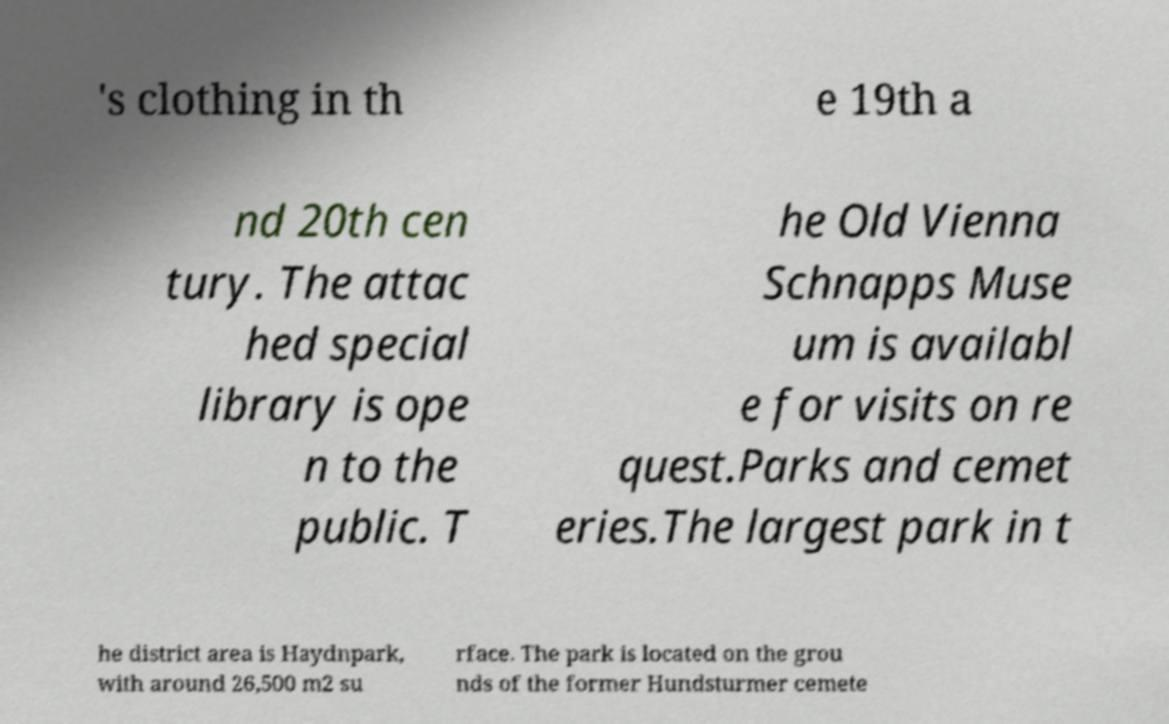Can you read and provide the text displayed in the image?This photo seems to have some interesting text. Can you extract and type it out for me? 's clothing in th e 19th a nd 20th cen tury. The attac hed special library is ope n to the public. T he Old Vienna Schnapps Muse um is availabl e for visits on re quest.Parks and cemet eries.The largest park in t he district area is Haydnpark, with around 26,500 m2 su rface. The park is located on the grou nds of the former Hundsturmer cemete 